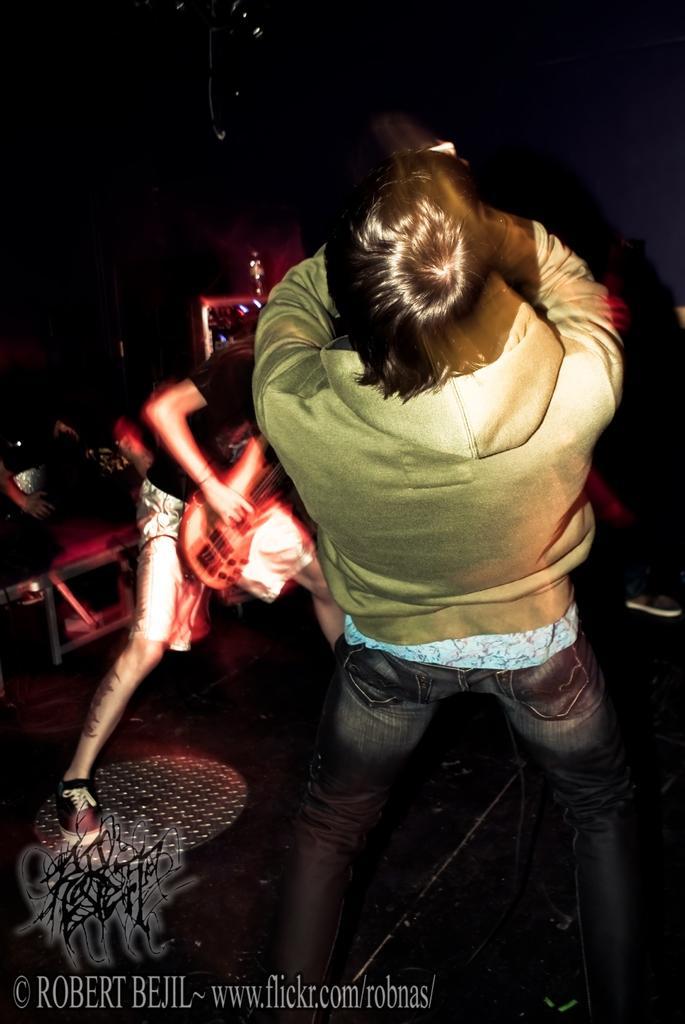In one or two sentences, can you explain what this image depicts? This green color jacket person is bending backwards. This person is playing a guitar. 